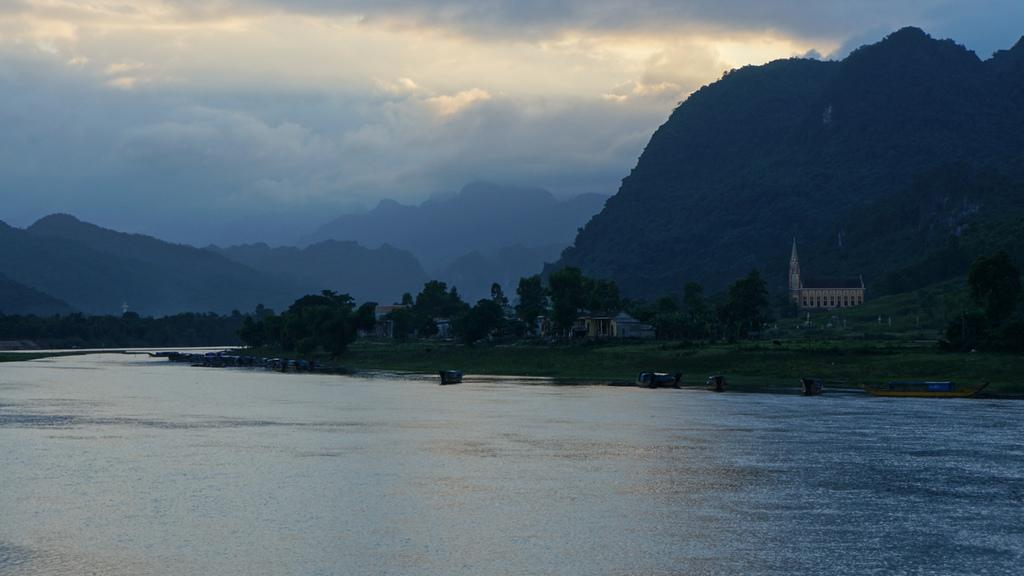What type of structures can be seen in the image? There is a group of buildings in the image. What other natural elements are present in the image? There are trees and water visible in the image. What can be seen in the distance in the image? There are mountains in the background of the image. How would you describe the weather in the image? The sky is cloudy in the background of the image. How many cherries are hanging from the hook in the image? There is no hook or cherry present in the image. How does the image show an increase in the number of mountains? The image does not show an increase in the number of mountains; it simply depicts the presence of mountains in the background. 